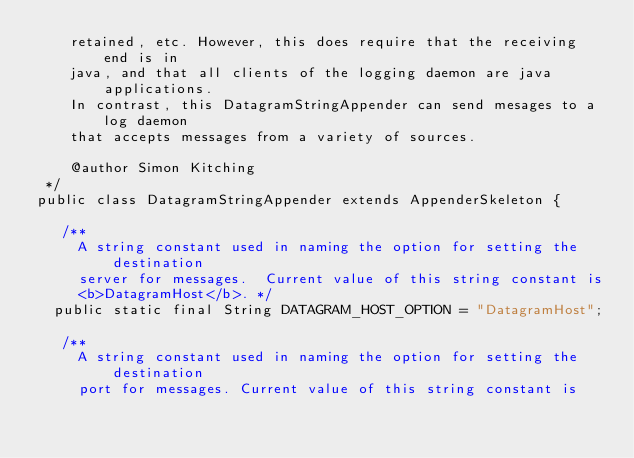<code> <loc_0><loc_0><loc_500><loc_500><_Java_>    retained, etc. However, this does require that the receiving end is in
    java, and that all clients of the logging daemon are java applications.
    In contrast, this DatagramStringAppender can send mesages to a log daemon
    that accepts messages from a variety of sources.

    @author Simon Kitching
 */
public class DatagramStringAppender extends AppenderSkeleton {

   /**
     A string constant used in naming the option for setting the destination
     server for messages.  Current value of this string constant is
     <b>DatagramHost</b>. */
  public static final String DATAGRAM_HOST_OPTION = "DatagramHost";

   /**
     A string constant used in naming the option for setting the destination
     port for messages. Current value of this string constant is</code> 